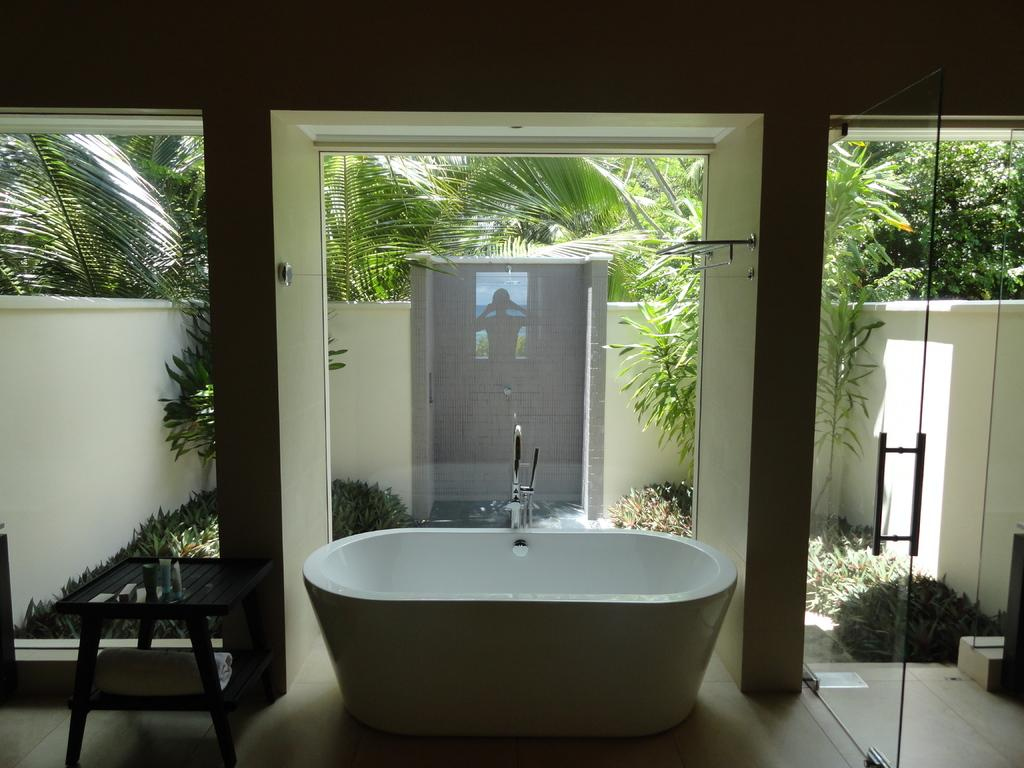What is the main object in the image? There is a bathtub in the image. What can be seen growing on the ground in the image? Plants are growing on the ground in the image. What is visible in the background of the image? There are trees visible in the background of the image. What type of wall can be seen in the image? There is no wall present in the image. 